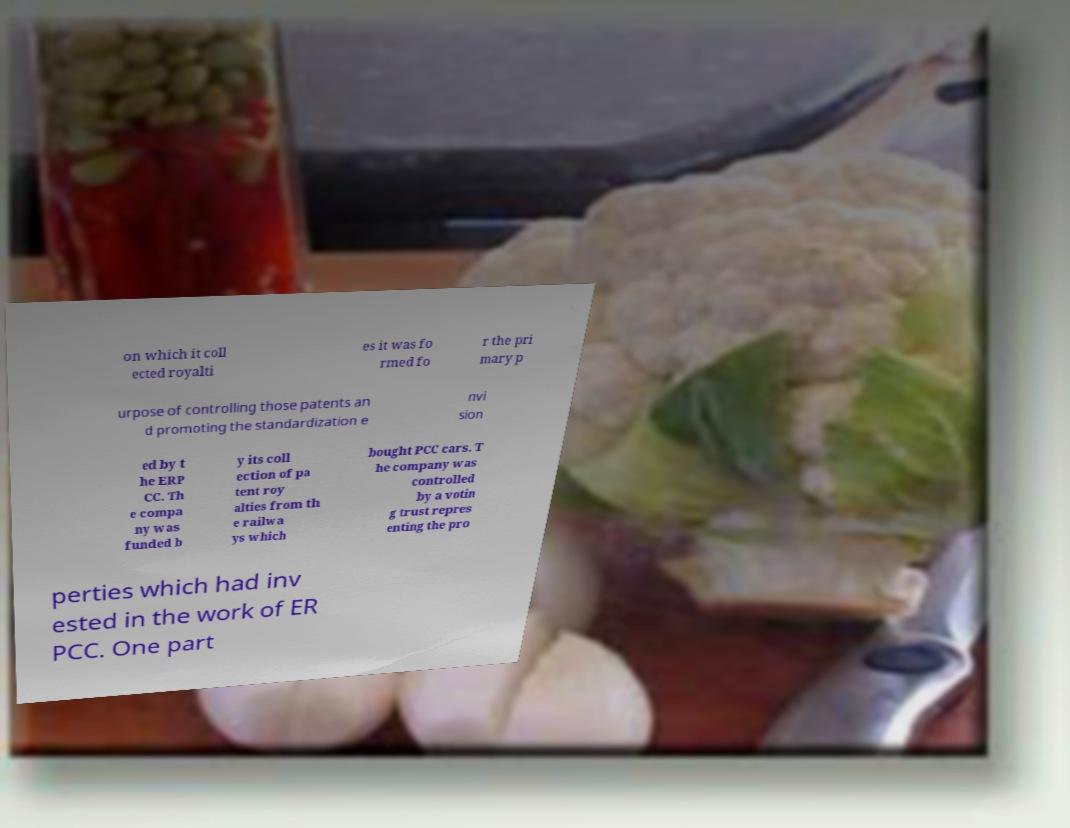What messages or text are displayed in this image? I need them in a readable, typed format. on which it coll ected royalti es it was fo rmed fo r the pri mary p urpose of controlling those patents an d promoting the standardization e nvi sion ed by t he ERP CC. Th e compa ny was funded b y its coll ection of pa tent roy alties from th e railwa ys which bought PCC cars. T he company was controlled by a votin g trust repres enting the pro perties which had inv ested in the work of ER PCC. One part 